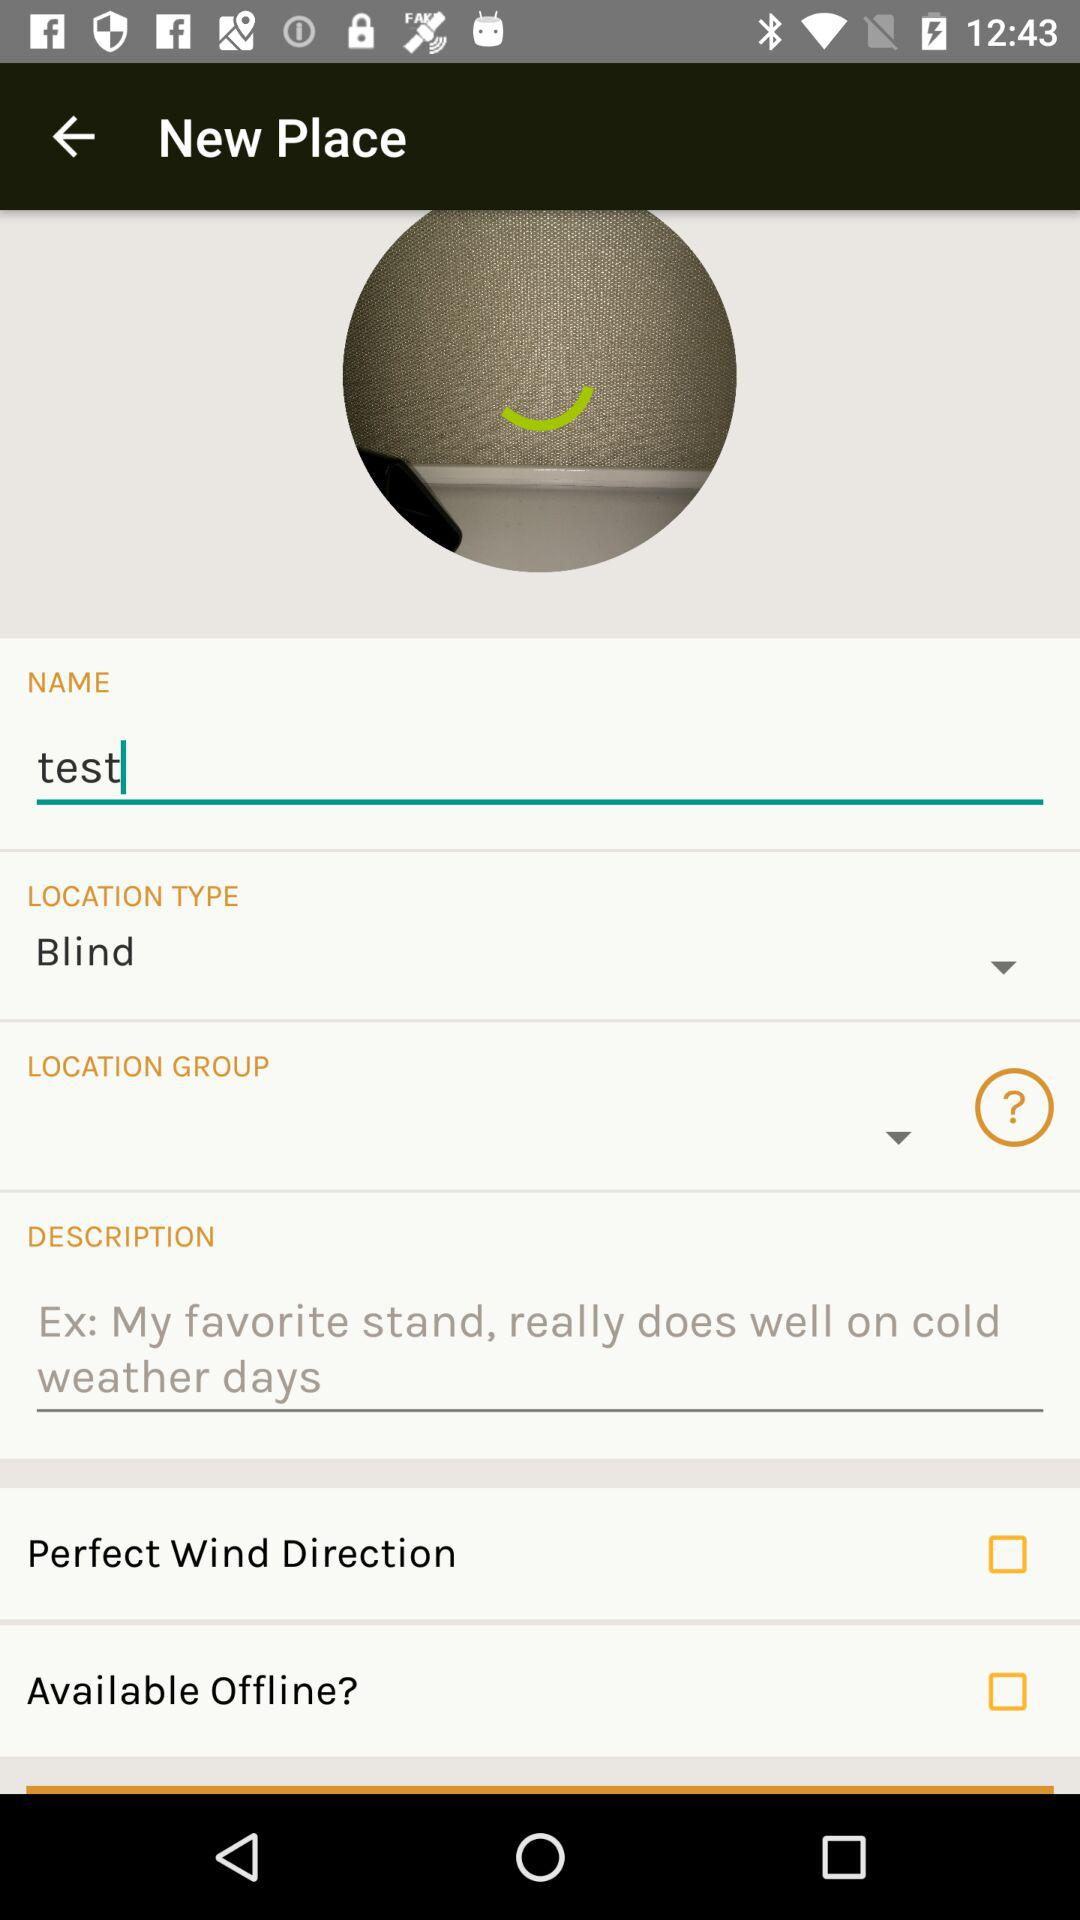What is the status of "Perfect Wind Direction"? The status is "off". 